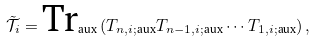<formula> <loc_0><loc_0><loc_500><loc_500>\tilde { \mathcal { T } } _ { i } = \text {Tr} _ { \text {aux} } \left ( T _ { n , i ; \text {aux} } T _ { n - 1 , i ; \text {aux} } \cdots T _ { 1 , i ; \text {aux} } \right ) ,</formula> 